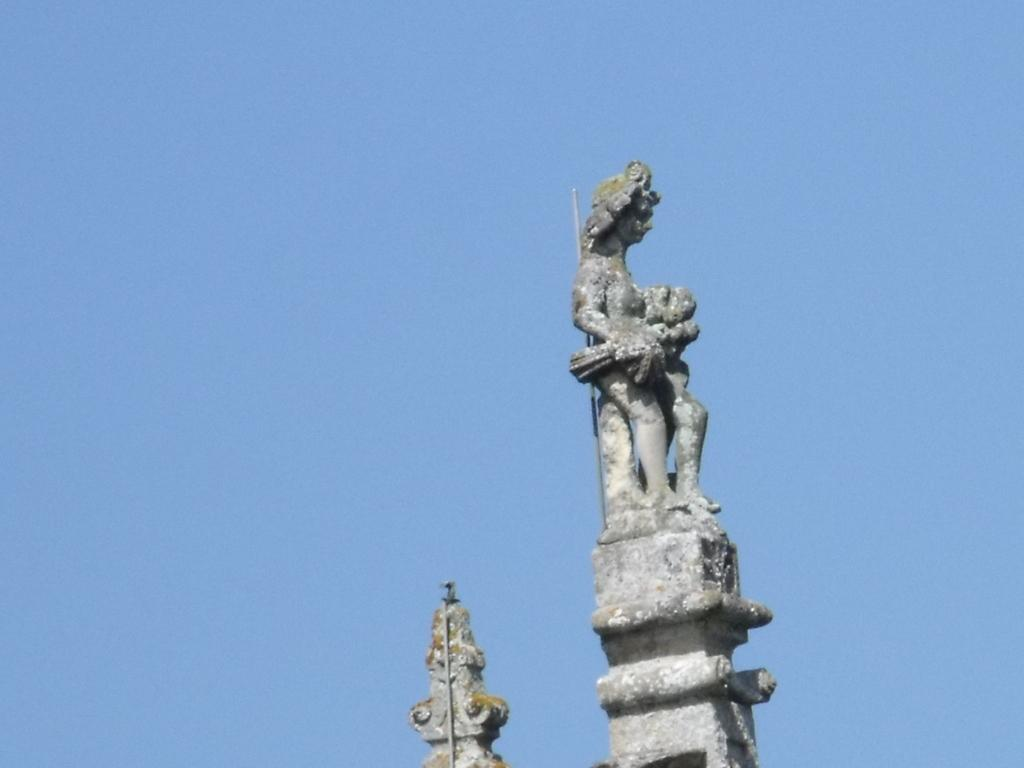What is: What is the main subject of the image? There is a statue of a woman in the image. What is the statue placed on? The statue is placed on top of a stone. What can be seen in the background of the image? The sky is visible in the background of the image. How many grapes are being pushed by the woman's stomach in the image? There are no grapes or any indication of the woman's stomach being involved in the image. 